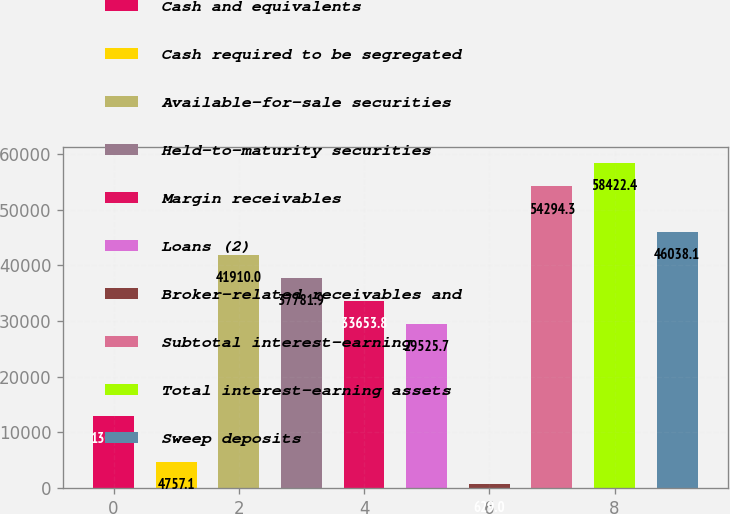Convert chart. <chart><loc_0><loc_0><loc_500><loc_500><bar_chart><fcel>Cash and equivalents<fcel>Cash required to be segregated<fcel>Available-for-sale securities<fcel>Held-to-maturity securities<fcel>Margin receivables<fcel>Loans (2)<fcel>Broker-related receivables and<fcel>Subtotal interest-earning<fcel>Total interest-earning assets<fcel>Sweep deposits<nl><fcel>13013.3<fcel>4757.1<fcel>41910<fcel>37781.9<fcel>33653.8<fcel>29525.7<fcel>629<fcel>54294.3<fcel>58422.4<fcel>46038.1<nl></chart> 